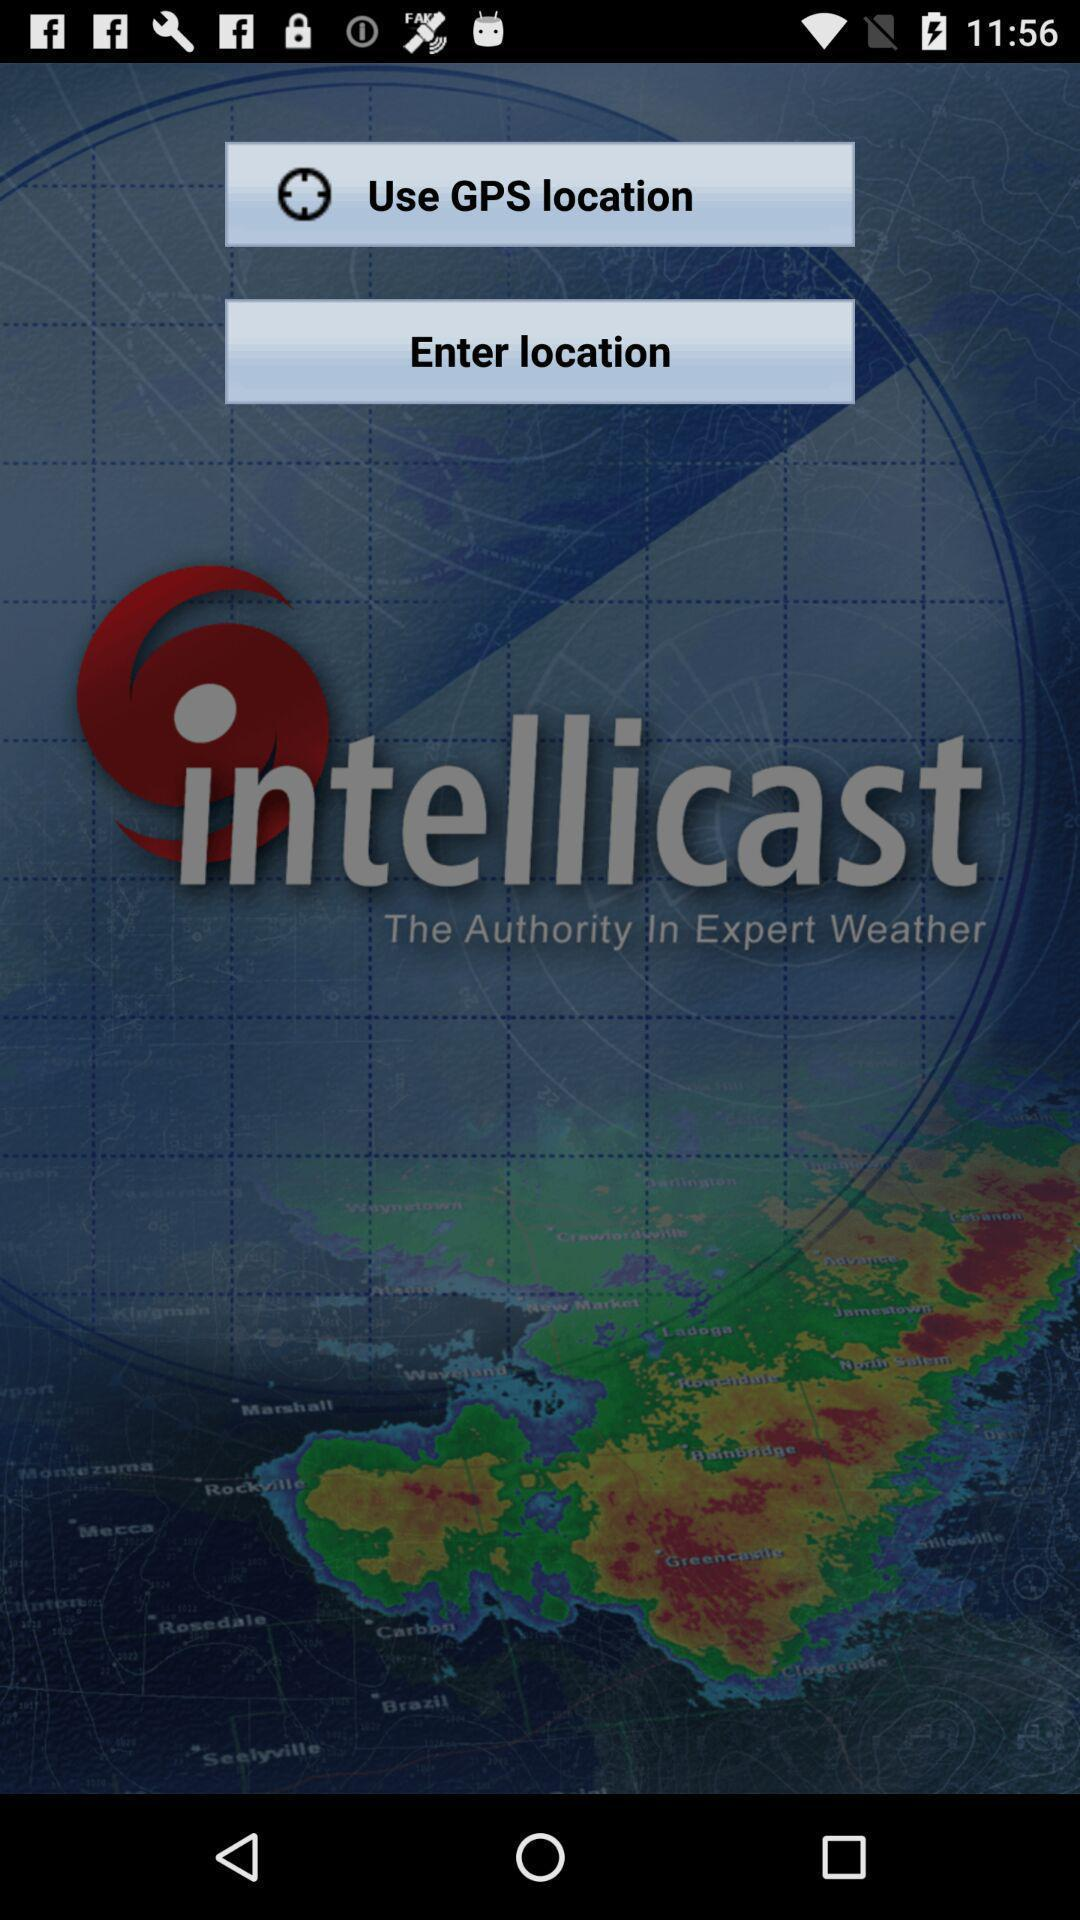Which options are given for the location? The given options are "Use GPS location" and "Enter location". 